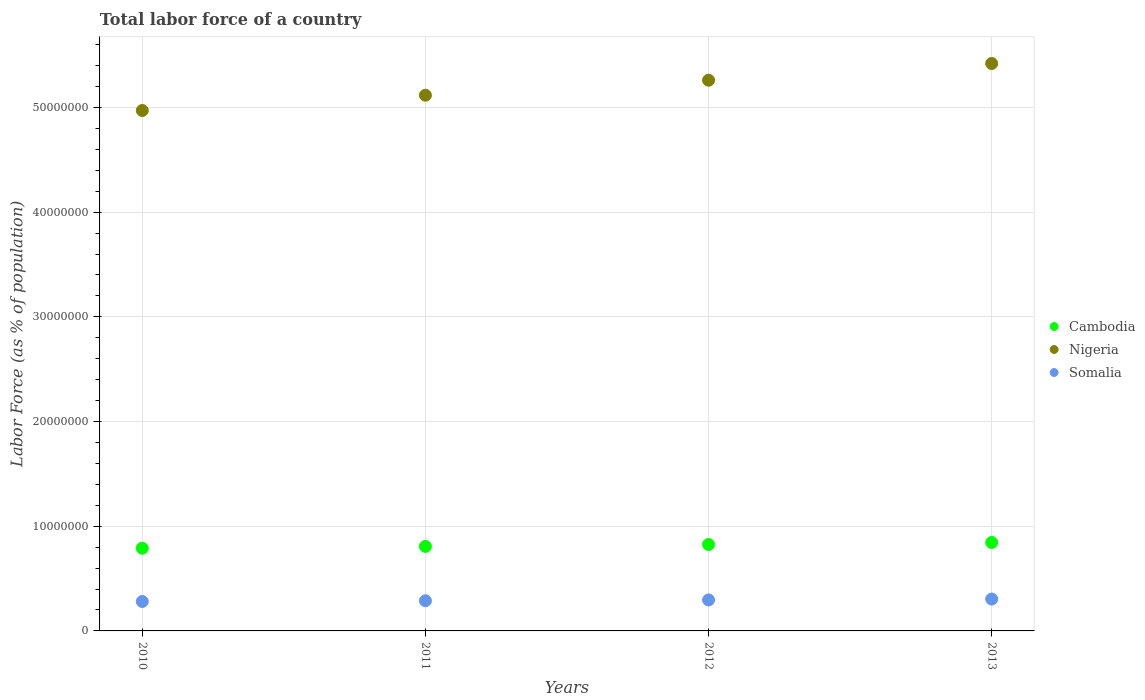How many different coloured dotlines are there?
Provide a short and direct response. 3. What is the percentage of labor force in Somalia in 2012?
Provide a short and direct response. 2.96e+06. Across all years, what is the maximum percentage of labor force in Somalia?
Give a very brief answer. 3.04e+06. Across all years, what is the minimum percentage of labor force in Cambodia?
Provide a succinct answer. 7.90e+06. In which year was the percentage of labor force in Nigeria maximum?
Keep it short and to the point. 2013. In which year was the percentage of labor force in Somalia minimum?
Your answer should be compact. 2010. What is the total percentage of labor force in Cambodia in the graph?
Your answer should be very brief. 3.27e+07. What is the difference between the percentage of labor force in Somalia in 2010 and that in 2011?
Your response must be concise. -6.90e+04. What is the difference between the percentage of labor force in Nigeria in 2013 and the percentage of labor force in Cambodia in 2010?
Give a very brief answer. 4.63e+07. What is the average percentage of labor force in Nigeria per year?
Your response must be concise. 5.19e+07. In the year 2013, what is the difference between the percentage of labor force in Somalia and percentage of labor force in Cambodia?
Offer a very short reply. -5.40e+06. What is the ratio of the percentage of labor force in Cambodia in 2011 to that in 2012?
Give a very brief answer. 0.98. Is the percentage of labor force in Cambodia in 2010 less than that in 2011?
Your answer should be compact. Yes. Is the difference between the percentage of labor force in Somalia in 2011 and 2012 greater than the difference between the percentage of labor force in Cambodia in 2011 and 2012?
Give a very brief answer. Yes. What is the difference between the highest and the second highest percentage of labor force in Somalia?
Your response must be concise. 8.51e+04. What is the difference between the highest and the lowest percentage of labor force in Cambodia?
Your answer should be very brief. 5.46e+05. Is it the case that in every year, the sum of the percentage of labor force in Nigeria and percentage of labor force in Cambodia  is greater than the percentage of labor force in Somalia?
Give a very brief answer. Yes. Is the percentage of labor force in Cambodia strictly less than the percentage of labor force in Somalia over the years?
Keep it short and to the point. No. Does the graph contain grids?
Your answer should be very brief. Yes. Where does the legend appear in the graph?
Provide a succinct answer. Center right. How many legend labels are there?
Give a very brief answer. 3. What is the title of the graph?
Provide a succinct answer. Total labor force of a country. Does "Jamaica" appear as one of the legend labels in the graph?
Keep it short and to the point. No. What is the label or title of the Y-axis?
Your answer should be very brief. Labor Force (as % of population). What is the Labor Force (as % of population) in Cambodia in 2010?
Provide a succinct answer. 7.90e+06. What is the Labor Force (as % of population) of Nigeria in 2010?
Give a very brief answer. 4.97e+07. What is the Labor Force (as % of population) of Somalia in 2010?
Keep it short and to the point. 2.81e+06. What is the Labor Force (as % of population) of Cambodia in 2011?
Provide a succinct answer. 8.08e+06. What is the Labor Force (as % of population) in Nigeria in 2011?
Offer a very short reply. 5.12e+07. What is the Labor Force (as % of population) of Somalia in 2011?
Your answer should be compact. 2.88e+06. What is the Labor Force (as % of population) in Cambodia in 2012?
Keep it short and to the point. 8.26e+06. What is the Labor Force (as % of population) in Nigeria in 2012?
Offer a terse response. 5.26e+07. What is the Labor Force (as % of population) of Somalia in 2012?
Provide a succinct answer. 2.96e+06. What is the Labor Force (as % of population) of Cambodia in 2013?
Your answer should be very brief. 8.45e+06. What is the Labor Force (as % of population) of Nigeria in 2013?
Your answer should be compact. 5.42e+07. What is the Labor Force (as % of population) in Somalia in 2013?
Offer a terse response. 3.04e+06. Across all years, what is the maximum Labor Force (as % of population) of Cambodia?
Provide a succinct answer. 8.45e+06. Across all years, what is the maximum Labor Force (as % of population) in Nigeria?
Provide a short and direct response. 5.42e+07. Across all years, what is the maximum Labor Force (as % of population) of Somalia?
Offer a terse response. 3.04e+06. Across all years, what is the minimum Labor Force (as % of population) in Cambodia?
Your answer should be very brief. 7.90e+06. Across all years, what is the minimum Labor Force (as % of population) in Nigeria?
Give a very brief answer. 4.97e+07. Across all years, what is the minimum Labor Force (as % of population) of Somalia?
Ensure brevity in your answer.  2.81e+06. What is the total Labor Force (as % of population) of Cambodia in the graph?
Ensure brevity in your answer.  3.27e+07. What is the total Labor Force (as % of population) in Nigeria in the graph?
Ensure brevity in your answer.  2.08e+08. What is the total Labor Force (as % of population) of Somalia in the graph?
Give a very brief answer. 1.17e+07. What is the difference between the Labor Force (as % of population) of Cambodia in 2010 and that in 2011?
Your response must be concise. -1.75e+05. What is the difference between the Labor Force (as % of population) in Nigeria in 2010 and that in 2011?
Make the answer very short. -1.46e+06. What is the difference between the Labor Force (as % of population) in Somalia in 2010 and that in 2011?
Ensure brevity in your answer.  -6.90e+04. What is the difference between the Labor Force (as % of population) in Cambodia in 2010 and that in 2012?
Make the answer very short. -3.60e+05. What is the difference between the Labor Force (as % of population) in Nigeria in 2010 and that in 2012?
Your answer should be very brief. -2.89e+06. What is the difference between the Labor Force (as % of population) of Somalia in 2010 and that in 2012?
Your answer should be very brief. -1.47e+05. What is the difference between the Labor Force (as % of population) of Cambodia in 2010 and that in 2013?
Provide a short and direct response. -5.46e+05. What is the difference between the Labor Force (as % of population) in Nigeria in 2010 and that in 2013?
Offer a very short reply. -4.49e+06. What is the difference between the Labor Force (as % of population) in Somalia in 2010 and that in 2013?
Your answer should be very brief. -2.32e+05. What is the difference between the Labor Force (as % of population) of Cambodia in 2011 and that in 2012?
Offer a terse response. -1.85e+05. What is the difference between the Labor Force (as % of population) in Nigeria in 2011 and that in 2012?
Give a very brief answer. -1.43e+06. What is the difference between the Labor Force (as % of population) of Somalia in 2011 and that in 2012?
Make the answer very short. -7.78e+04. What is the difference between the Labor Force (as % of population) of Cambodia in 2011 and that in 2013?
Keep it short and to the point. -3.70e+05. What is the difference between the Labor Force (as % of population) in Nigeria in 2011 and that in 2013?
Provide a short and direct response. -3.03e+06. What is the difference between the Labor Force (as % of population) of Somalia in 2011 and that in 2013?
Ensure brevity in your answer.  -1.63e+05. What is the difference between the Labor Force (as % of population) of Cambodia in 2012 and that in 2013?
Keep it short and to the point. -1.85e+05. What is the difference between the Labor Force (as % of population) of Nigeria in 2012 and that in 2013?
Offer a terse response. -1.60e+06. What is the difference between the Labor Force (as % of population) of Somalia in 2012 and that in 2013?
Your response must be concise. -8.51e+04. What is the difference between the Labor Force (as % of population) in Cambodia in 2010 and the Labor Force (as % of population) in Nigeria in 2011?
Keep it short and to the point. -4.33e+07. What is the difference between the Labor Force (as % of population) in Cambodia in 2010 and the Labor Force (as % of population) in Somalia in 2011?
Offer a terse response. 5.02e+06. What is the difference between the Labor Force (as % of population) in Nigeria in 2010 and the Labor Force (as % of population) in Somalia in 2011?
Give a very brief answer. 4.68e+07. What is the difference between the Labor Force (as % of population) of Cambodia in 2010 and the Labor Force (as % of population) of Nigeria in 2012?
Keep it short and to the point. -4.47e+07. What is the difference between the Labor Force (as % of population) of Cambodia in 2010 and the Labor Force (as % of population) of Somalia in 2012?
Offer a terse response. 4.94e+06. What is the difference between the Labor Force (as % of population) in Nigeria in 2010 and the Labor Force (as % of population) in Somalia in 2012?
Keep it short and to the point. 4.67e+07. What is the difference between the Labor Force (as % of population) in Cambodia in 2010 and the Labor Force (as % of population) in Nigeria in 2013?
Offer a terse response. -4.63e+07. What is the difference between the Labor Force (as % of population) of Cambodia in 2010 and the Labor Force (as % of population) of Somalia in 2013?
Ensure brevity in your answer.  4.86e+06. What is the difference between the Labor Force (as % of population) of Nigeria in 2010 and the Labor Force (as % of population) of Somalia in 2013?
Keep it short and to the point. 4.67e+07. What is the difference between the Labor Force (as % of population) of Cambodia in 2011 and the Labor Force (as % of population) of Nigeria in 2012?
Your response must be concise. -4.45e+07. What is the difference between the Labor Force (as % of population) of Cambodia in 2011 and the Labor Force (as % of population) of Somalia in 2012?
Ensure brevity in your answer.  5.12e+06. What is the difference between the Labor Force (as % of population) in Nigeria in 2011 and the Labor Force (as % of population) in Somalia in 2012?
Your response must be concise. 4.82e+07. What is the difference between the Labor Force (as % of population) of Cambodia in 2011 and the Labor Force (as % of population) of Nigeria in 2013?
Provide a succinct answer. -4.61e+07. What is the difference between the Labor Force (as % of population) in Cambodia in 2011 and the Labor Force (as % of population) in Somalia in 2013?
Make the answer very short. 5.03e+06. What is the difference between the Labor Force (as % of population) in Nigeria in 2011 and the Labor Force (as % of population) in Somalia in 2013?
Offer a terse response. 4.81e+07. What is the difference between the Labor Force (as % of population) in Cambodia in 2012 and the Labor Force (as % of population) in Nigeria in 2013?
Keep it short and to the point. -4.59e+07. What is the difference between the Labor Force (as % of population) of Cambodia in 2012 and the Labor Force (as % of population) of Somalia in 2013?
Your answer should be compact. 5.22e+06. What is the difference between the Labor Force (as % of population) in Nigeria in 2012 and the Labor Force (as % of population) in Somalia in 2013?
Ensure brevity in your answer.  4.96e+07. What is the average Labor Force (as % of population) of Cambodia per year?
Offer a very short reply. 8.17e+06. What is the average Labor Force (as % of population) in Nigeria per year?
Offer a terse response. 5.19e+07. What is the average Labor Force (as % of population) of Somalia per year?
Provide a succinct answer. 2.92e+06. In the year 2010, what is the difference between the Labor Force (as % of population) of Cambodia and Labor Force (as % of population) of Nigeria?
Ensure brevity in your answer.  -4.18e+07. In the year 2010, what is the difference between the Labor Force (as % of population) in Cambodia and Labor Force (as % of population) in Somalia?
Provide a succinct answer. 5.09e+06. In the year 2010, what is the difference between the Labor Force (as % of population) in Nigeria and Labor Force (as % of population) in Somalia?
Offer a very short reply. 4.69e+07. In the year 2011, what is the difference between the Labor Force (as % of population) in Cambodia and Labor Force (as % of population) in Nigeria?
Your answer should be compact. -4.31e+07. In the year 2011, what is the difference between the Labor Force (as % of population) in Cambodia and Labor Force (as % of population) in Somalia?
Your answer should be compact. 5.20e+06. In the year 2011, what is the difference between the Labor Force (as % of population) in Nigeria and Labor Force (as % of population) in Somalia?
Your answer should be compact. 4.83e+07. In the year 2012, what is the difference between the Labor Force (as % of population) of Cambodia and Labor Force (as % of population) of Nigeria?
Provide a succinct answer. -4.43e+07. In the year 2012, what is the difference between the Labor Force (as % of population) of Cambodia and Labor Force (as % of population) of Somalia?
Keep it short and to the point. 5.30e+06. In the year 2012, what is the difference between the Labor Force (as % of population) of Nigeria and Labor Force (as % of population) of Somalia?
Your answer should be compact. 4.96e+07. In the year 2013, what is the difference between the Labor Force (as % of population) in Cambodia and Labor Force (as % of population) in Nigeria?
Give a very brief answer. -4.58e+07. In the year 2013, what is the difference between the Labor Force (as % of population) in Cambodia and Labor Force (as % of population) in Somalia?
Your response must be concise. 5.40e+06. In the year 2013, what is the difference between the Labor Force (as % of population) of Nigeria and Labor Force (as % of population) of Somalia?
Give a very brief answer. 5.12e+07. What is the ratio of the Labor Force (as % of population) of Cambodia in 2010 to that in 2011?
Offer a terse response. 0.98. What is the ratio of the Labor Force (as % of population) of Nigeria in 2010 to that in 2011?
Provide a short and direct response. 0.97. What is the ratio of the Labor Force (as % of population) of Somalia in 2010 to that in 2011?
Your response must be concise. 0.98. What is the ratio of the Labor Force (as % of population) of Cambodia in 2010 to that in 2012?
Your answer should be compact. 0.96. What is the ratio of the Labor Force (as % of population) of Nigeria in 2010 to that in 2012?
Give a very brief answer. 0.94. What is the ratio of the Labor Force (as % of population) in Somalia in 2010 to that in 2012?
Keep it short and to the point. 0.95. What is the ratio of the Labor Force (as % of population) in Cambodia in 2010 to that in 2013?
Keep it short and to the point. 0.94. What is the ratio of the Labor Force (as % of population) of Nigeria in 2010 to that in 2013?
Your answer should be very brief. 0.92. What is the ratio of the Labor Force (as % of population) of Somalia in 2010 to that in 2013?
Provide a succinct answer. 0.92. What is the ratio of the Labor Force (as % of population) in Cambodia in 2011 to that in 2012?
Provide a short and direct response. 0.98. What is the ratio of the Labor Force (as % of population) of Nigeria in 2011 to that in 2012?
Your answer should be compact. 0.97. What is the ratio of the Labor Force (as % of population) of Somalia in 2011 to that in 2012?
Give a very brief answer. 0.97. What is the ratio of the Labor Force (as % of population) of Cambodia in 2011 to that in 2013?
Offer a very short reply. 0.96. What is the ratio of the Labor Force (as % of population) of Nigeria in 2011 to that in 2013?
Offer a terse response. 0.94. What is the ratio of the Labor Force (as % of population) in Somalia in 2011 to that in 2013?
Offer a very short reply. 0.95. What is the ratio of the Labor Force (as % of population) of Cambodia in 2012 to that in 2013?
Offer a very short reply. 0.98. What is the ratio of the Labor Force (as % of population) in Nigeria in 2012 to that in 2013?
Offer a terse response. 0.97. What is the ratio of the Labor Force (as % of population) of Somalia in 2012 to that in 2013?
Give a very brief answer. 0.97. What is the difference between the highest and the second highest Labor Force (as % of population) of Cambodia?
Ensure brevity in your answer.  1.85e+05. What is the difference between the highest and the second highest Labor Force (as % of population) of Nigeria?
Provide a short and direct response. 1.60e+06. What is the difference between the highest and the second highest Labor Force (as % of population) in Somalia?
Make the answer very short. 8.51e+04. What is the difference between the highest and the lowest Labor Force (as % of population) of Cambodia?
Give a very brief answer. 5.46e+05. What is the difference between the highest and the lowest Labor Force (as % of population) of Nigeria?
Your answer should be very brief. 4.49e+06. What is the difference between the highest and the lowest Labor Force (as % of population) of Somalia?
Your answer should be very brief. 2.32e+05. 